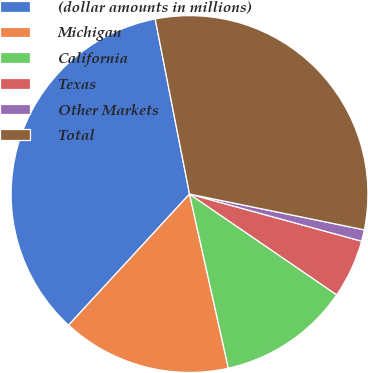<chart> <loc_0><loc_0><loc_500><loc_500><pie_chart><fcel>(dollar amounts in millions)<fcel>Michigan<fcel>California<fcel>Texas<fcel>Other Markets<fcel>Total<nl><fcel>35.06%<fcel>15.35%<fcel>11.95%<fcel>5.3%<fcel>1.04%<fcel>31.3%<nl></chart> 